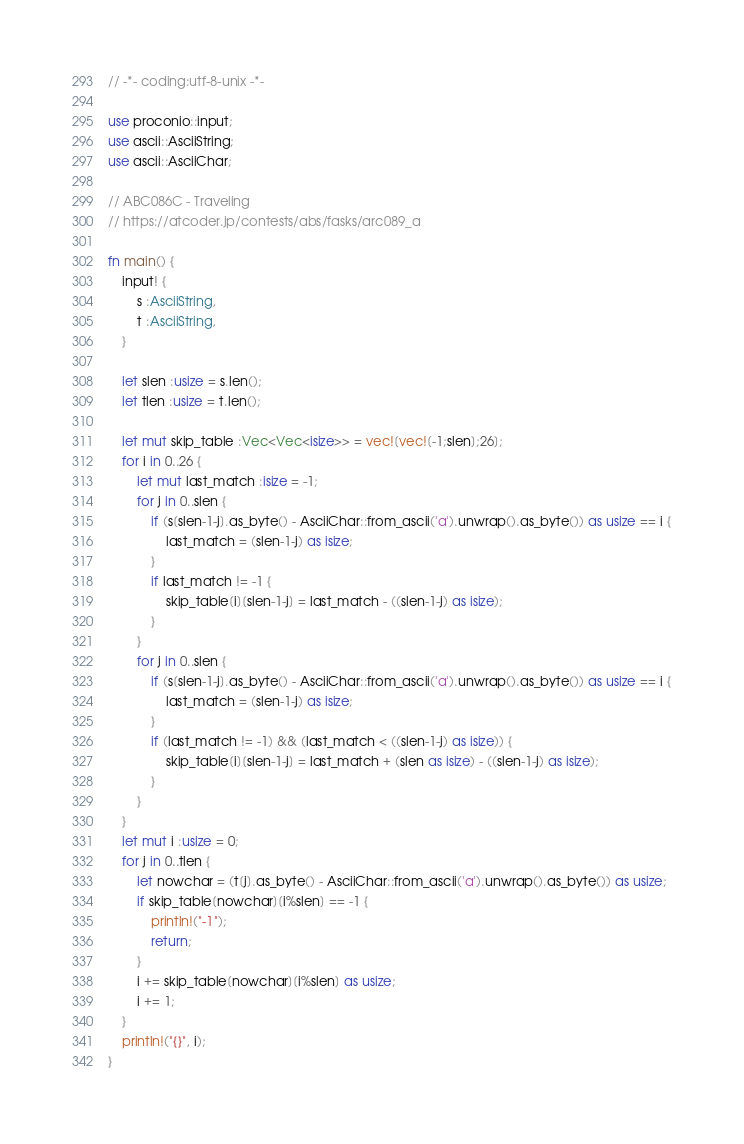Convert code to text. <code><loc_0><loc_0><loc_500><loc_500><_Rust_>// -*- coding:utf-8-unix -*-

use proconio::input;
use ascii::AsciiString;
use ascii::AsciiChar;

// ABC086C - Traveling
// https://atcoder.jp/contests/abs/fasks/arc089_a

fn main() {
    input! {
        s :AsciiString,
        t :AsciiString,
    }

    let slen :usize = s.len();
    let tlen :usize = t.len();

    let mut skip_table :Vec<Vec<isize>> = vec![vec![-1;slen];26];
    for i in 0..26 {
        let mut last_match :isize = -1;
        for j in 0..slen {
            if (s[slen-1-j].as_byte() - AsciiChar::from_ascii('a').unwrap().as_byte()) as usize == i {
                last_match = (slen-1-j) as isize;
            }
            if last_match != -1 {
                skip_table[i][slen-1-j] = last_match - ((slen-1-j) as isize);
            }
        }
        for j in 0..slen {
            if (s[slen-1-j].as_byte() - AsciiChar::from_ascii('a').unwrap().as_byte()) as usize == i {
                last_match = (slen-1-j) as isize;
            }
            if (last_match != -1) && (last_match < ((slen-1-j) as isize)) {
                skip_table[i][slen-1-j] = last_match + (slen as isize) - ((slen-1-j) as isize);
            }
        }
    }
    let mut i :usize = 0;
    for j in 0..tlen {
        let nowchar = (t[j].as_byte() - AsciiChar::from_ascii('a').unwrap().as_byte()) as usize;
        if skip_table[nowchar][i%slen] == -1 {
            println!("-1");
            return;
        }
        i += skip_table[nowchar][i%slen] as usize;
        i += 1;
    }
    println!("{}", i);
}
</code> 